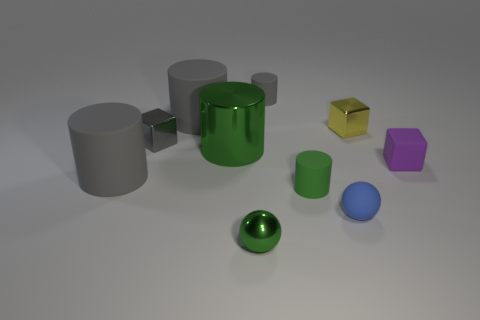What is the shape of the tiny rubber object behind the tiny block that is to the left of the tiny shiny sphere?
Provide a short and direct response. Cylinder. There is a matte object that is the same color as the large metal cylinder; what shape is it?
Provide a succinct answer. Cylinder. There is a cylinder that is made of the same material as the tiny green ball; what size is it?
Offer a terse response. Large. Is there anything else that is the same color as the rubber cube?
Your response must be concise. No. What is the material of the tiny block that is left of the yellow cube on the right side of the big object behind the gray metal cube?
Provide a short and direct response. Metal. What number of rubber objects are either yellow blocks or small blue things?
Keep it short and to the point. 1. Do the large metal object and the tiny metallic ball have the same color?
Offer a terse response. Yes. What number of things are either large green rubber things or gray rubber objects on the right side of the green metal cylinder?
Make the answer very short. 1. There is a gray cylinder that is in front of the purple cube; is it the same size as the big green metallic cylinder?
Provide a short and direct response. Yes. What number of other objects are the same shape as the tiny gray matte thing?
Give a very brief answer. 4. 